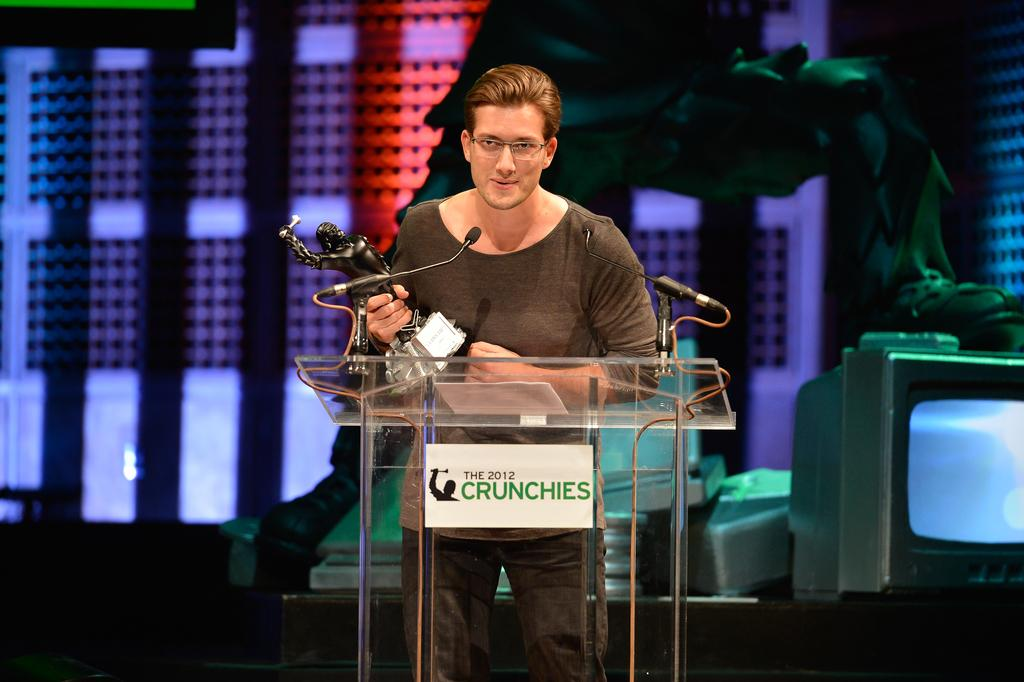Provide a one-sentence caption for the provided image. A man holding a trophy speaks into a microphone at the Crunchies awards. 